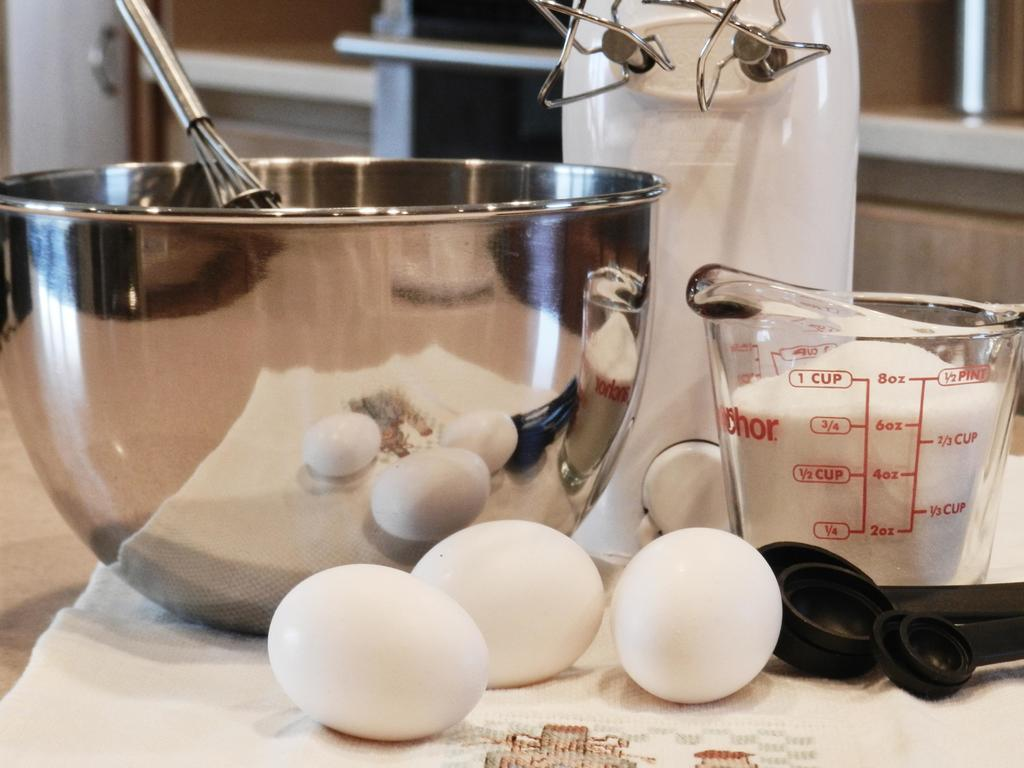Provide a one-sentence caption for the provided image. A mixing bowl with 6oz of sugar in a glass jar sits on a table. 